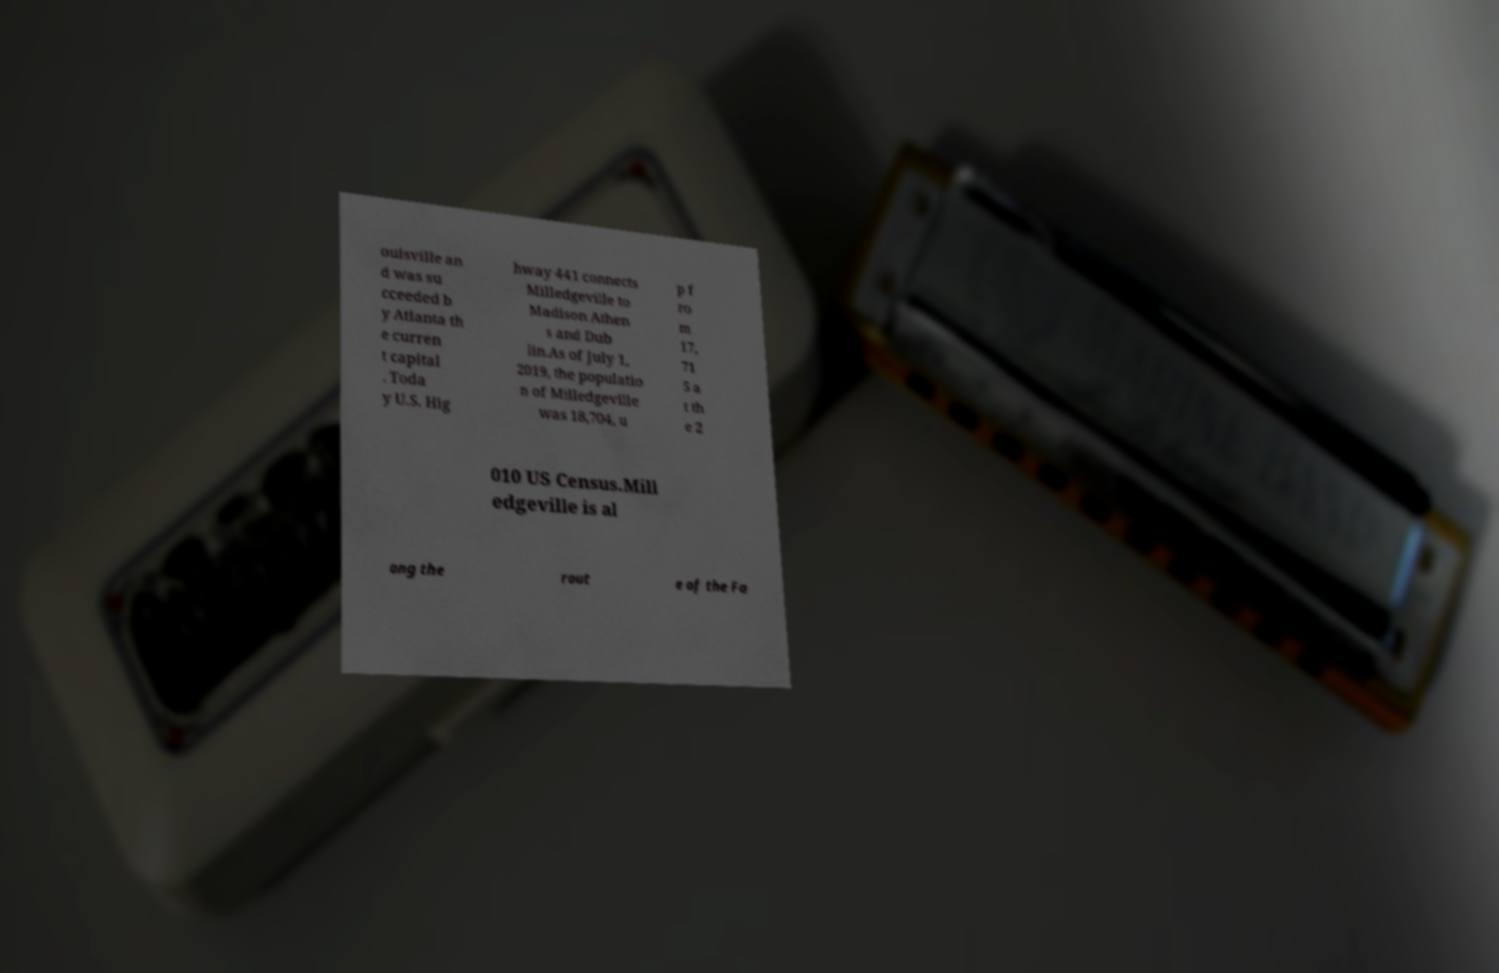Please identify and transcribe the text found in this image. ouisville an d was su cceeded b y Atlanta th e curren t capital . Toda y U.S. Hig hway 441 connects Milledgeville to Madison Athen s and Dub lin.As of July 1, 2019, the populatio n of Milledgeville was 18,704, u p f ro m 17, 71 5 a t th e 2 010 US Census.Mill edgeville is al ong the rout e of the Fa 